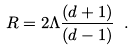<formula> <loc_0><loc_0><loc_500><loc_500>R = 2 \Lambda \frac { ( d + 1 ) } { ( d - 1 ) } \ .</formula> 